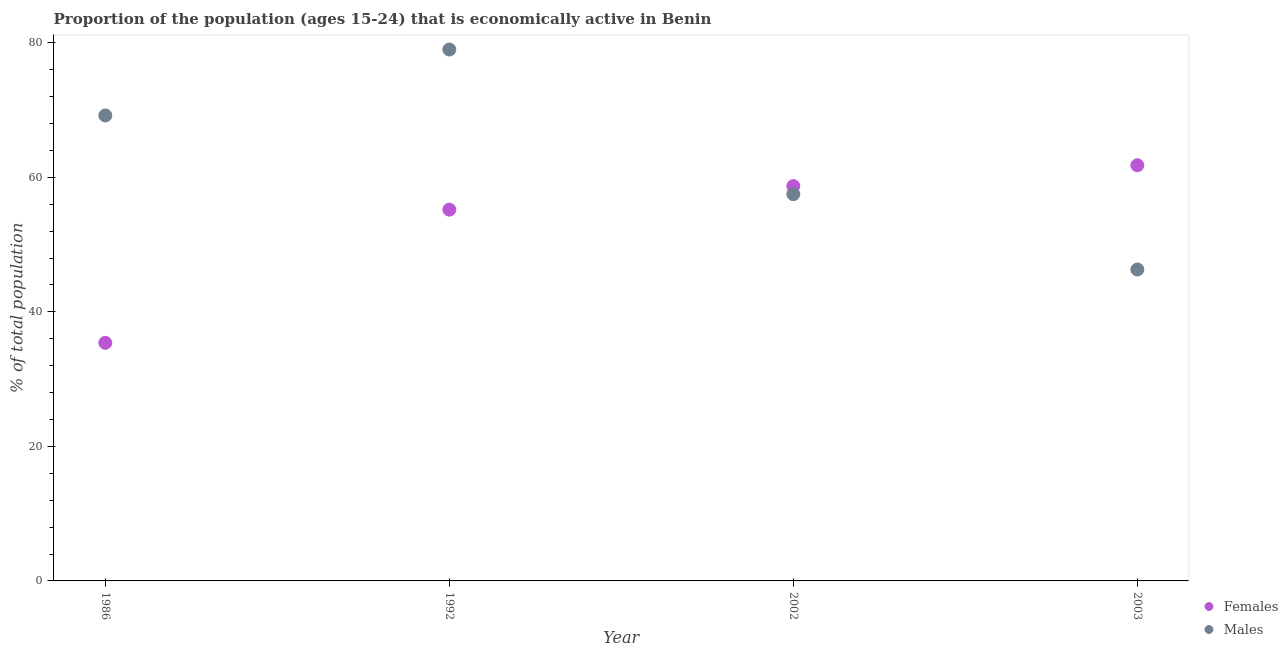How many different coloured dotlines are there?
Ensure brevity in your answer.  2. Is the number of dotlines equal to the number of legend labels?
Keep it short and to the point. Yes. What is the percentage of economically active male population in 1992?
Offer a terse response. 79. Across all years, what is the maximum percentage of economically active male population?
Your answer should be very brief. 79. Across all years, what is the minimum percentage of economically active female population?
Your answer should be very brief. 35.4. In which year was the percentage of economically active male population maximum?
Provide a succinct answer. 1992. What is the total percentage of economically active female population in the graph?
Keep it short and to the point. 211.1. What is the difference between the percentage of economically active female population in 1986 and that in 2003?
Give a very brief answer. -26.4. What is the difference between the percentage of economically active male population in 2002 and the percentage of economically active female population in 1986?
Give a very brief answer. 22.1. What is the average percentage of economically active female population per year?
Offer a very short reply. 52.78. In the year 2003, what is the difference between the percentage of economically active male population and percentage of economically active female population?
Your response must be concise. -15.5. What is the ratio of the percentage of economically active female population in 1986 to that in 1992?
Your answer should be compact. 0.64. Is the percentage of economically active female population in 2002 less than that in 2003?
Your answer should be compact. Yes. Is the difference between the percentage of economically active female population in 1992 and 2003 greater than the difference between the percentage of economically active male population in 1992 and 2003?
Provide a succinct answer. No. What is the difference between the highest and the second highest percentage of economically active female population?
Your answer should be very brief. 3.1. What is the difference between the highest and the lowest percentage of economically active male population?
Your answer should be compact. 32.7. In how many years, is the percentage of economically active male population greater than the average percentage of economically active male population taken over all years?
Make the answer very short. 2. Is the percentage of economically active female population strictly greater than the percentage of economically active male population over the years?
Provide a short and direct response. No. Is the percentage of economically active female population strictly less than the percentage of economically active male population over the years?
Keep it short and to the point. No. How many years are there in the graph?
Keep it short and to the point. 4. Are the values on the major ticks of Y-axis written in scientific E-notation?
Keep it short and to the point. No. Does the graph contain grids?
Your answer should be compact. No. How many legend labels are there?
Your answer should be very brief. 2. How are the legend labels stacked?
Your response must be concise. Vertical. What is the title of the graph?
Your answer should be compact. Proportion of the population (ages 15-24) that is economically active in Benin. What is the label or title of the Y-axis?
Provide a succinct answer. % of total population. What is the % of total population in Females in 1986?
Ensure brevity in your answer.  35.4. What is the % of total population in Males in 1986?
Your answer should be very brief. 69.2. What is the % of total population of Females in 1992?
Make the answer very short. 55.2. What is the % of total population of Males in 1992?
Your response must be concise. 79. What is the % of total population of Females in 2002?
Provide a short and direct response. 58.7. What is the % of total population in Males in 2002?
Offer a very short reply. 57.5. What is the % of total population in Females in 2003?
Provide a succinct answer. 61.8. What is the % of total population of Males in 2003?
Ensure brevity in your answer.  46.3. Across all years, what is the maximum % of total population in Females?
Offer a terse response. 61.8. Across all years, what is the maximum % of total population in Males?
Provide a succinct answer. 79. Across all years, what is the minimum % of total population of Females?
Keep it short and to the point. 35.4. Across all years, what is the minimum % of total population of Males?
Your answer should be very brief. 46.3. What is the total % of total population in Females in the graph?
Ensure brevity in your answer.  211.1. What is the total % of total population of Males in the graph?
Give a very brief answer. 252. What is the difference between the % of total population of Females in 1986 and that in 1992?
Your answer should be compact. -19.8. What is the difference between the % of total population of Females in 1986 and that in 2002?
Provide a short and direct response. -23.3. What is the difference between the % of total population of Females in 1986 and that in 2003?
Provide a succinct answer. -26.4. What is the difference between the % of total population of Males in 1986 and that in 2003?
Offer a terse response. 22.9. What is the difference between the % of total population of Females in 1992 and that in 2002?
Offer a very short reply. -3.5. What is the difference between the % of total population in Males in 1992 and that in 2002?
Give a very brief answer. 21.5. What is the difference between the % of total population of Males in 1992 and that in 2003?
Offer a terse response. 32.7. What is the difference between the % of total population in Females in 2002 and that in 2003?
Your answer should be compact. -3.1. What is the difference between the % of total population of Females in 1986 and the % of total population of Males in 1992?
Provide a short and direct response. -43.6. What is the difference between the % of total population of Females in 1986 and the % of total population of Males in 2002?
Provide a succinct answer. -22.1. What is the average % of total population of Females per year?
Make the answer very short. 52.77. In the year 1986, what is the difference between the % of total population of Females and % of total population of Males?
Make the answer very short. -33.8. In the year 1992, what is the difference between the % of total population of Females and % of total population of Males?
Ensure brevity in your answer.  -23.8. In the year 2002, what is the difference between the % of total population of Females and % of total population of Males?
Offer a very short reply. 1.2. What is the ratio of the % of total population of Females in 1986 to that in 1992?
Give a very brief answer. 0.64. What is the ratio of the % of total population in Males in 1986 to that in 1992?
Your answer should be very brief. 0.88. What is the ratio of the % of total population of Females in 1986 to that in 2002?
Offer a very short reply. 0.6. What is the ratio of the % of total population in Males in 1986 to that in 2002?
Provide a short and direct response. 1.2. What is the ratio of the % of total population in Females in 1986 to that in 2003?
Your answer should be compact. 0.57. What is the ratio of the % of total population in Males in 1986 to that in 2003?
Ensure brevity in your answer.  1.49. What is the ratio of the % of total population of Females in 1992 to that in 2002?
Offer a very short reply. 0.94. What is the ratio of the % of total population in Males in 1992 to that in 2002?
Your answer should be very brief. 1.37. What is the ratio of the % of total population in Females in 1992 to that in 2003?
Give a very brief answer. 0.89. What is the ratio of the % of total population of Males in 1992 to that in 2003?
Provide a short and direct response. 1.71. What is the ratio of the % of total population in Females in 2002 to that in 2003?
Offer a terse response. 0.95. What is the ratio of the % of total population in Males in 2002 to that in 2003?
Offer a very short reply. 1.24. What is the difference between the highest and the second highest % of total population of Females?
Provide a succinct answer. 3.1. What is the difference between the highest and the lowest % of total population of Females?
Offer a very short reply. 26.4. What is the difference between the highest and the lowest % of total population of Males?
Keep it short and to the point. 32.7. 